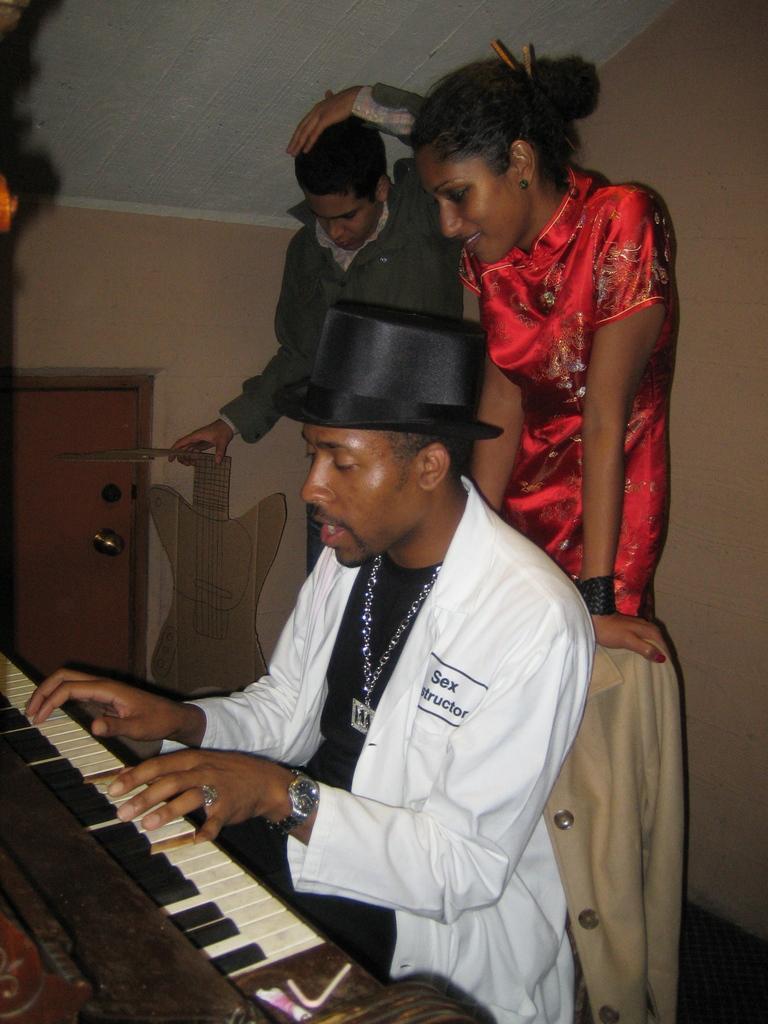In one or two sentences, can you explain what this image depicts? At the top we can see ceiling. This is a door. This is a wall. Here we can see two persons standing behind the chair. Here we can see a man wearing a black colour hat and playing a musical instrument called piano. He wore watch. 